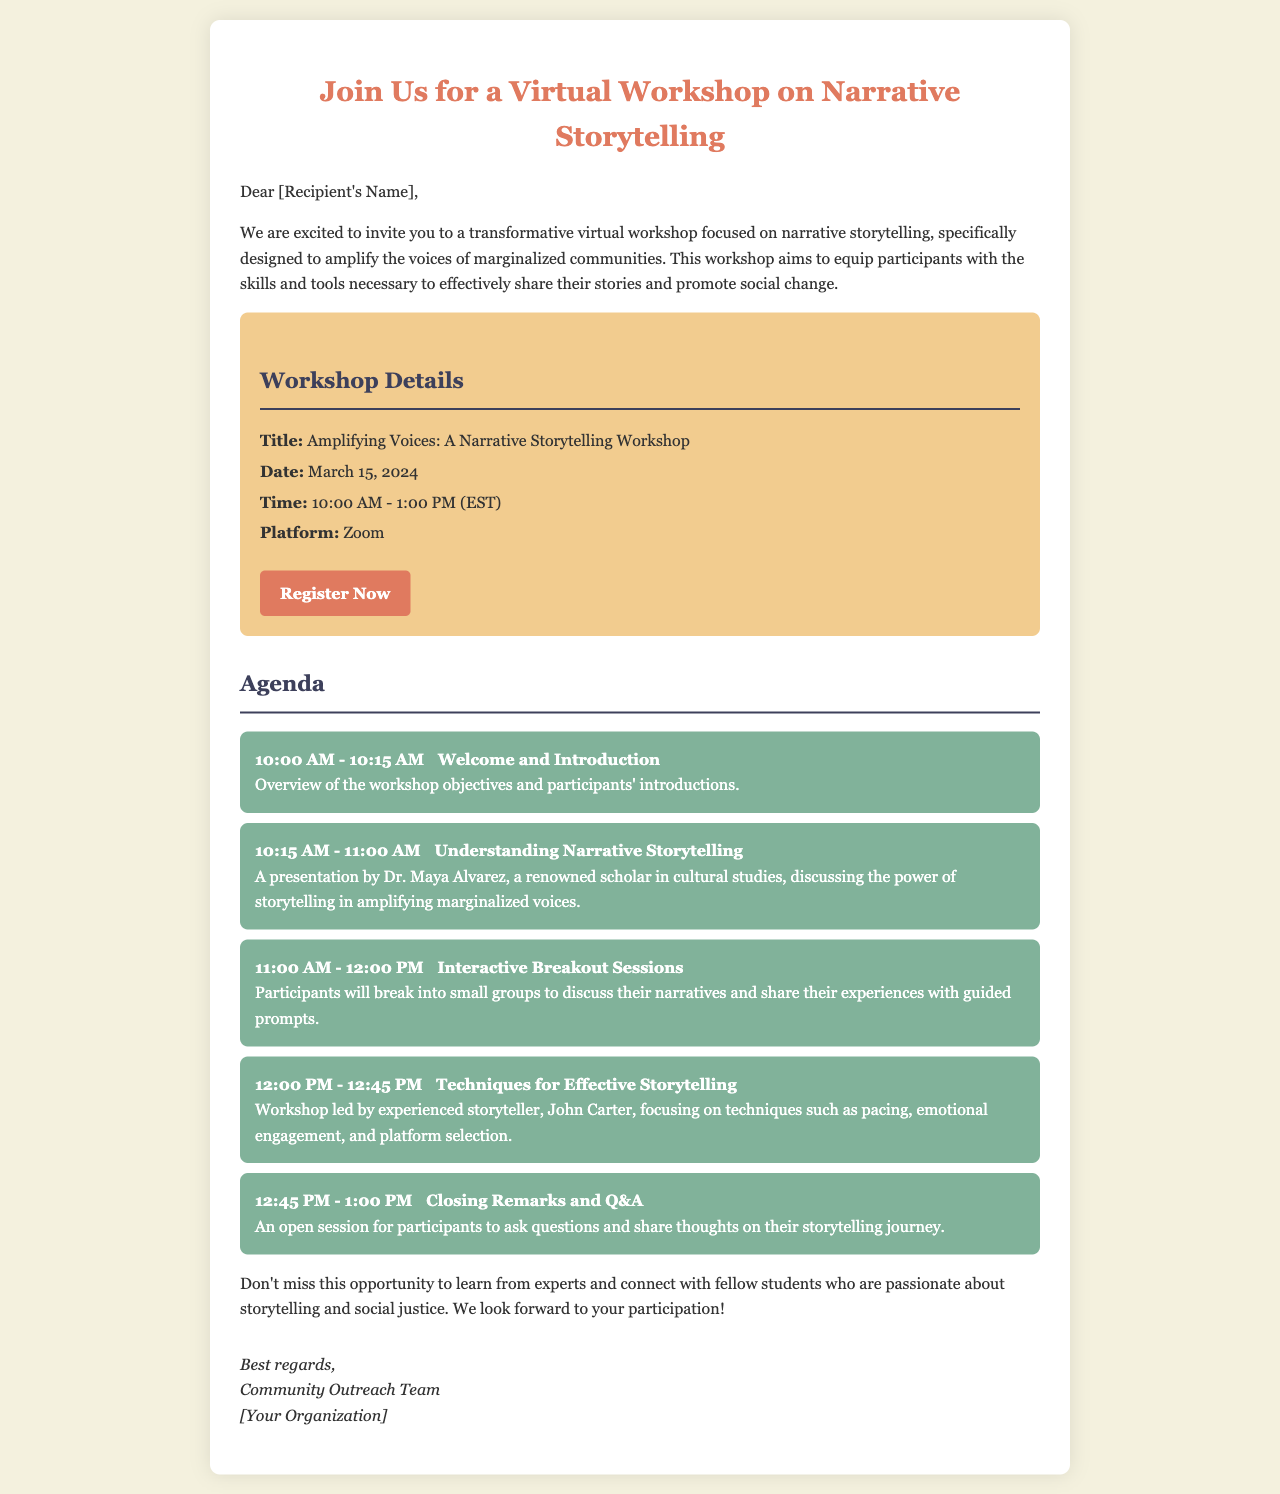What is the workshop title? The title of the workshop is listed under "Workshop Details."
Answer: Amplifying Voices: A Narrative Storytelling Workshop When is the workshop scheduled? The date for the workshop is mentioned in the "Workshop Details" section.
Answer: March 15, 2024 What is the duration of the workshop? The time noted in the "Workshop Details" specifies the start and end time of the workshop.
Answer: 3 hours Who will lead the session on Techniques for Effective Storytelling? This information is found in the agenda section under the relevant workshop item.
Answer: John Carter What is the primary goal of the workshop? The workshop's aim is described in the introductory paragraph.
Answer: To amplify the voices of marginalized communities How many breakout sessions are there in the agenda? Count the number of items listed in the agenda under the breakout sessions section.
Answer: 1 What platform will the workshop be hosted on? The platform is stated in the "Workshop Details."
Answer: Zoom What is the time for the Closing Remarks and Q&A? The time for this segment is indicated in the agenda.
Answer: 12:45 PM - 1:00 PM How can participants register for the workshop? The registration method is provided via a link in the "Workshop Details."
Answer: Click on the "Register Now" link 